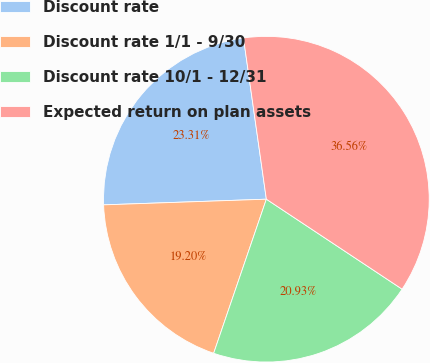<chart> <loc_0><loc_0><loc_500><loc_500><pie_chart><fcel>Discount rate<fcel>Discount rate 1/1 - 9/30<fcel>Discount rate 10/1 - 12/31<fcel>Expected return on plan assets<nl><fcel>23.31%<fcel>19.2%<fcel>20.93%<fcel>36.56%<nl></chart> 